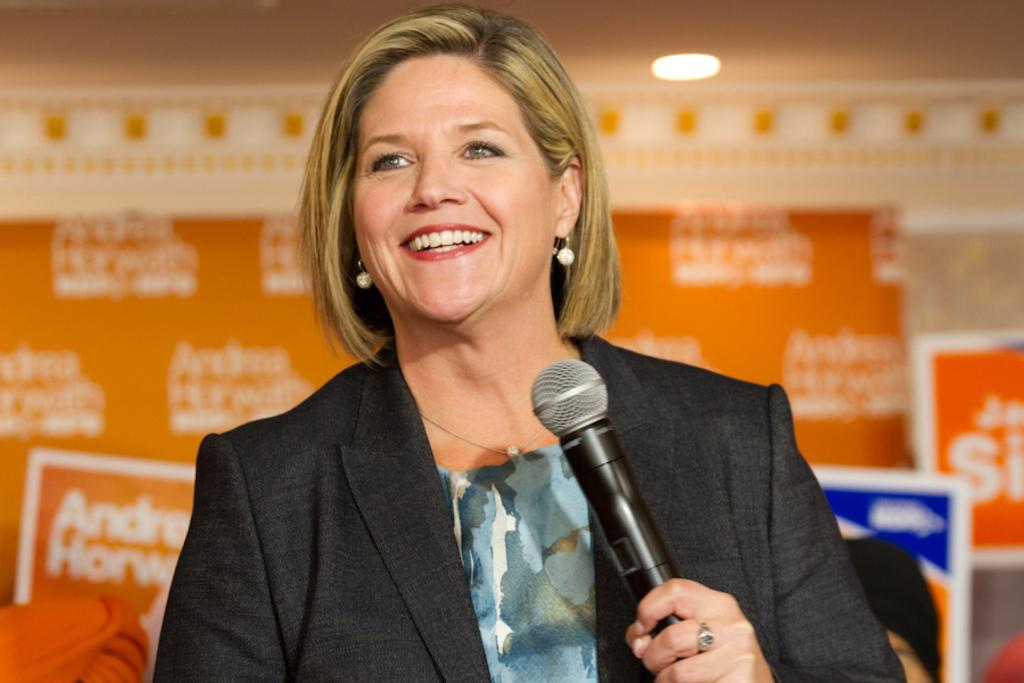What is: Who is the main subject in the image? There is a lady person in the image. What is the lady person wearing? The lady person is wearing a black color suit. What is the lady person holding in her hand? The lady person is holding a microphone in her left hand. How much celery is visible in the image? There is no celery present in the image. What type of grain is being harvested in the background of the image? There is no background or harvesting activity depicted in the image. 